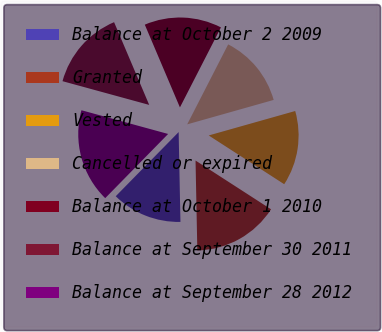Convert chart to OTSL. <chart><loc_0><loc_0><loc_500><loc_500><pie_chart><fcel>Balance at October 2 2009<fcel>Granted<fcel>Vested<fcel>Cancelled or expired<fcel>Balance at October 1 2010<fcel>Balance at September 30 2011<fcel>Balance at September 28 2012<nl><fcel>12.66%<fcel>15.56%<fcel>13.51%<fcel>13.08%<fcel>13.93%<fcel>14.36%<fcel>16.91%<nl></chart> 